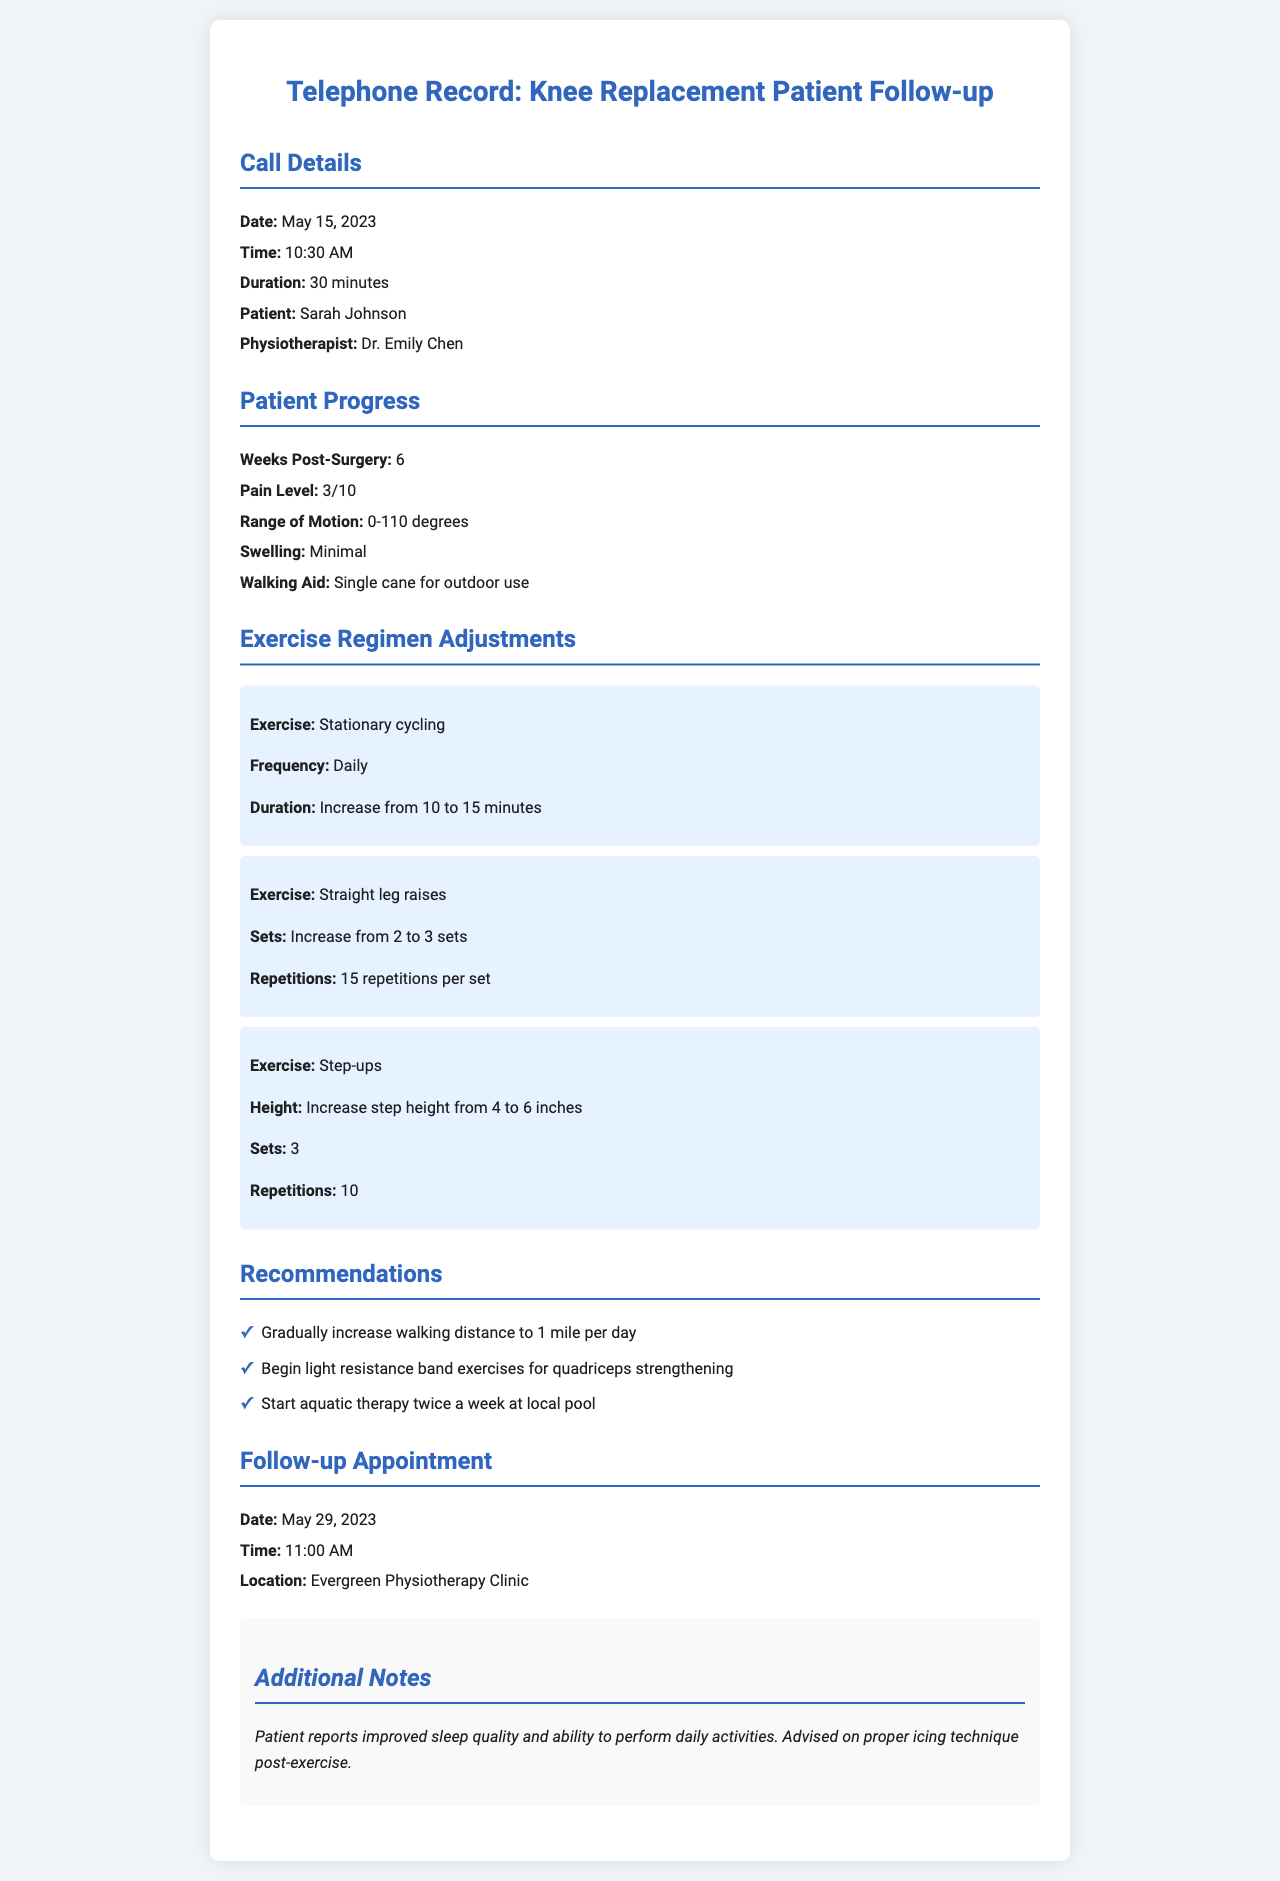what is the patient's name? The patient's name is listed prominently in the call details section of the document.
Answer: Sarah Johnson what is the date of the follow-up appointment? The follow-up appointment date is specified in the follow-up section of the document.
Answer: May 29, 2023 what is the pain level reported by the patient? The pain level is detailed in the patient progress section of the document.
Answer: 3/10 how many weeks post-surgery is the patient? The number of weeks post-surgery is provided in the patient progress section.
Answer: 6 what is the new duration for stationary cycling? The new duration for stationary cycling is listed under exercise regimen adjustments.
Answer: 15 minutes how many repetitions are now required for straight leg raises? The required repetitions are stated in the exercise regimen adjustments part of the document.
Answer: 15 repetitions per set which exercise has an increased step height? The exercise that has an increased step height is mentioned in the exercise regimen adjustments.
Answer: Step-ups where is the follow-up appointment taking place? The location of the follow-up appointment is specified in the follow-up section of the document.
Answer: Evergreen Physiotherapy Clinic what additional notes were mentioned about the patient's condition? The additional notes provide specific observations related to the patient's recovery.
Answer: Improved sleep quality and ability to perform daily activities 